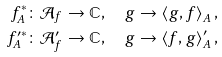Convert formula to latex. <formula><loc_0><loc_0><loc_500><loc_500>f _ { A } ^ { \ast } & \colon \mathcal { A } _ { f } \rightarrow \mathbb { C } , \quad g \rightarrow \left \langle g , f \right \rangle _ { A } , \\ f _ { A } ^ { \prime \ast } & \colon \mathcal { A } _ { f } ^ { \prime } \rightarrow \mathbb { C } , \quad g \rightarrow \left \langle f , g \right \rangle _ { A } ^ { \prime } ,</formula> 